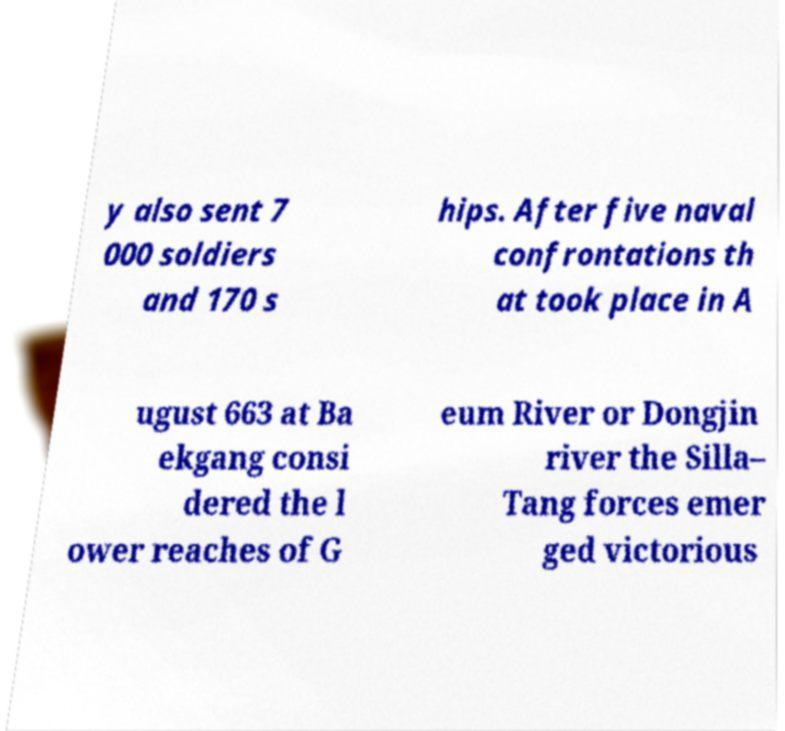For documentation purposes, I need the text within this image transcribed. Could you provide that? y also sent 7 000 soldiers and 170 s hips. After five naval confrontations th at took place in A ugust 663 at Ba ekgang consi dered the l ower reaches of G eum River or Dongjin river the Silla– Tang forces emer ged victorious 